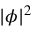<formula> <loc_0><loc_0><loc_500><loc_500>| \phi | ^ { 2 }</formula> 